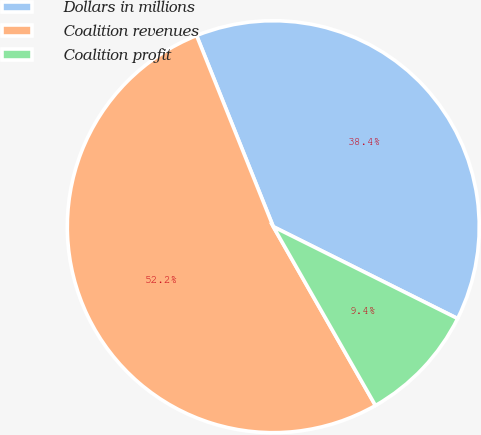<chart> <loc_0><loc_0><loc_500><loc_500><pie_chart><fcel>Dollars in millions<fcel>Coalition revenues<fcel>Coalition profit<nl><fcel>38.43%<fcel>52.19%<fcel>9.38%<nl></chart> 